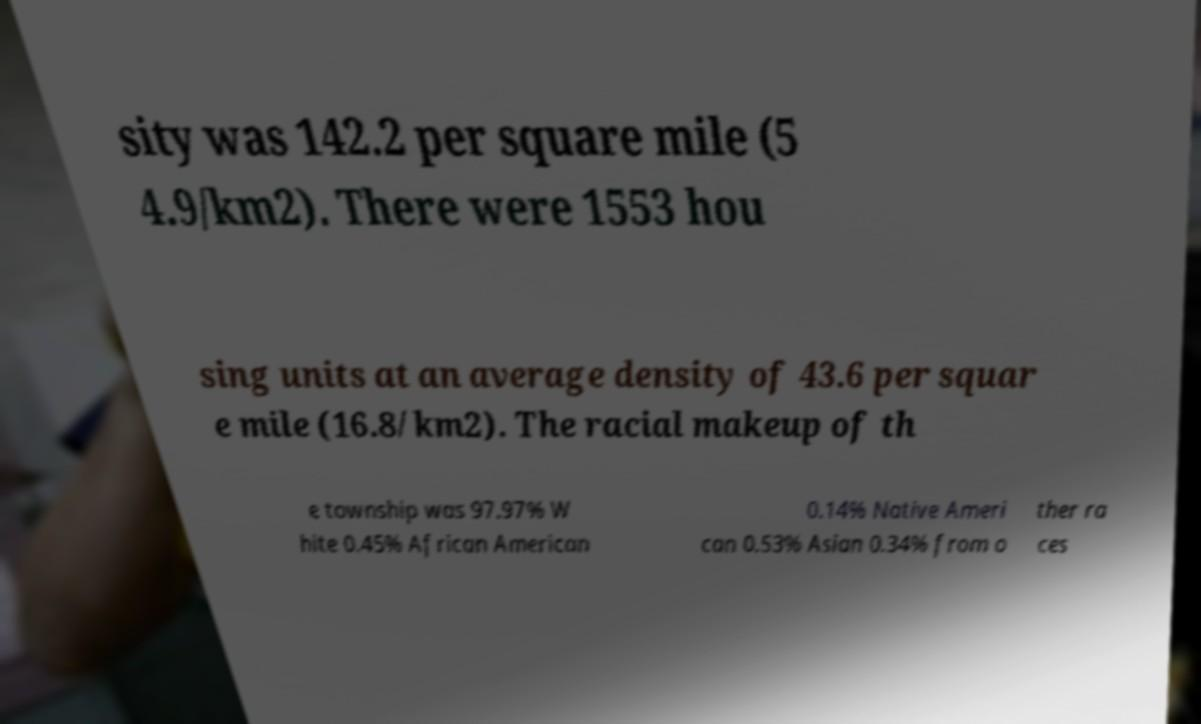Please identify and transcribe the text found in this image. sity was 142.2 per square mile (5 4.9/km2). There were 1553 hou sing units at an average density of 43.6 per squar e mile (16.8/km2). The racial makeup of th e township was 97.97% W hite 0.45% African American 0.14% Native Ameri can 0.53% Asian 0.34% from o ther ra ces 